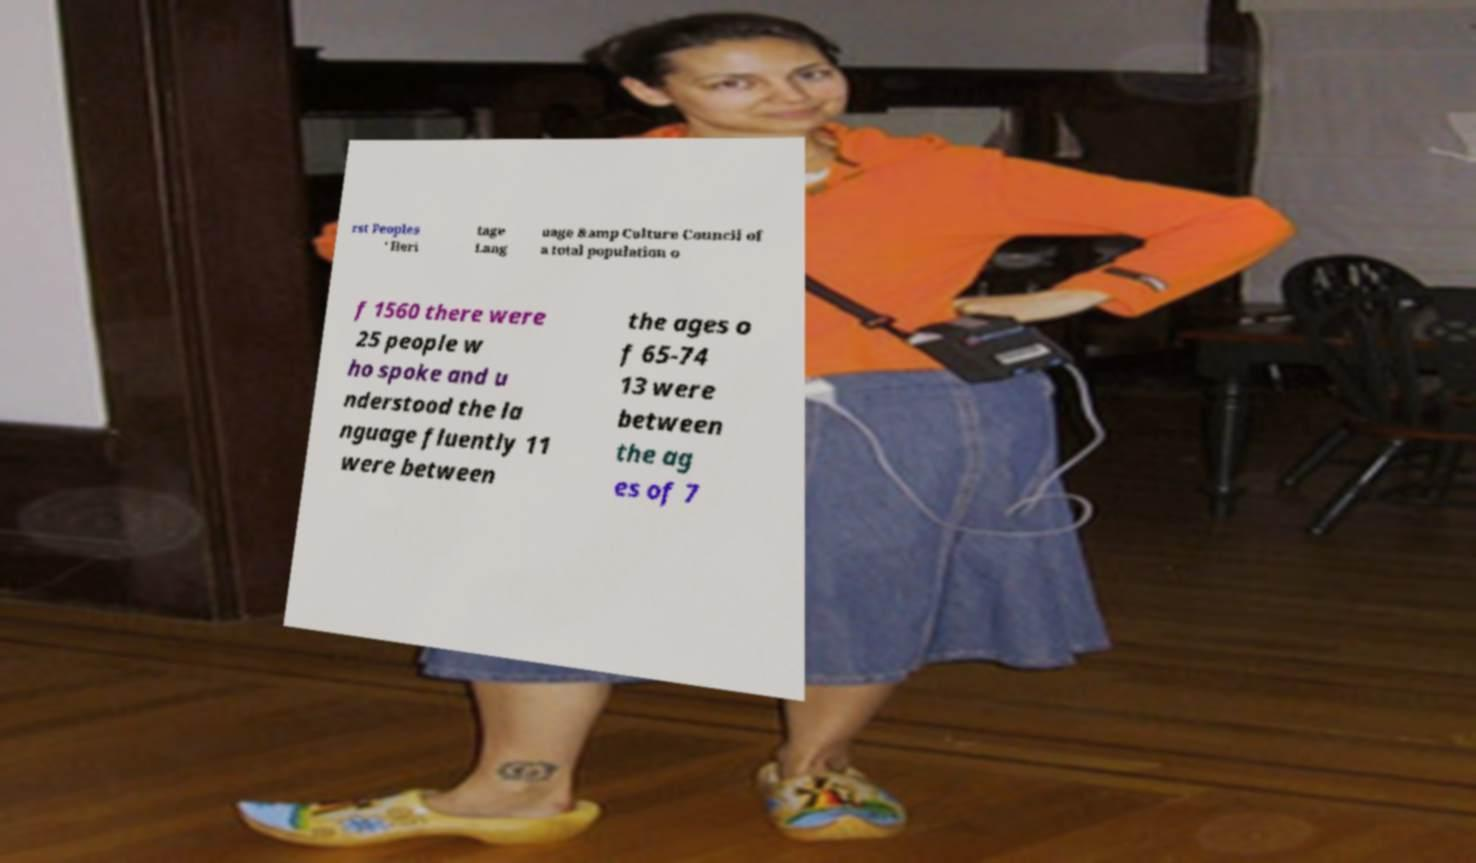Can you read and provide the text displayed in the image?This photo seems to have some interesting text. Can you extract and type it out for me? rst Peoples ' Heri tage Lang uage &amp Culture Council of a total population o f 1560 there were 25 people w ho spoke and u nderstood the la nguage fluently 11 were between the ages o f 65-74 13 were between the ag es of 7 